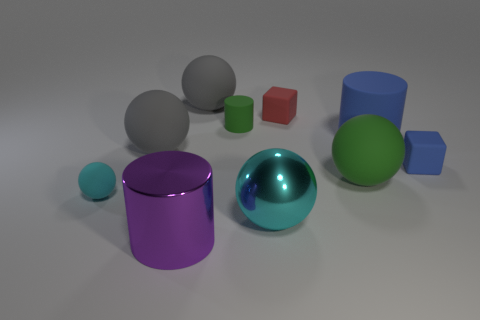Subtract all small matte cylinders. How many cylinders are left? 2 Subtract 2 spheres. How many spheres are left? 3 Subtract all red blocks. How many blocks are left? 1 Subtract all cylinders. How many objects are left? 7 Subtract 1 purple cylinders. How many objects are left? 9 Subtract all brown cylinders. Subtract all gray spheres. How many cylinders are left? 3 Subtract all blue spheres. How many purple cylinders are left? 1 Subtract all blue blocks. Subtract all small blue objects. How many objects are left? 8 Add 3 blue rubber cubes. How many blue rubber cubes are left? 4 Add 8 green things. How many green things exist? 10 